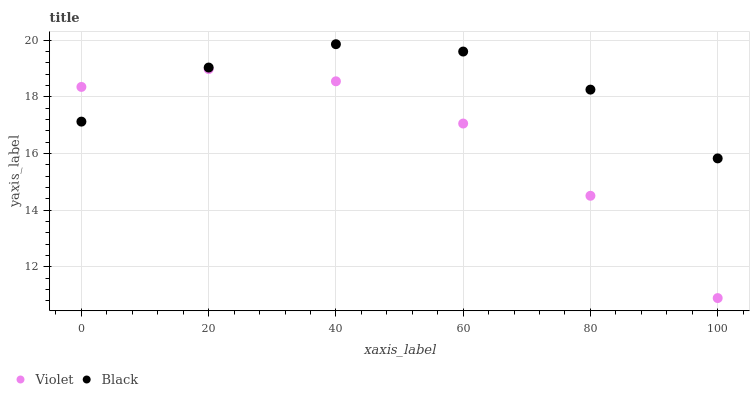Does Violet have the minimum area under the curve?
Answer yes or no. Yes. Does Black have the maximum area under the curve?
Answer yes or no. Yes. Does Violet have the maximum area under the curve?
Answer yes or no. No. Is Violet the smoothest?
Answer yes or no. Yes. Is Black the roughest?
Answer yes or no. Yes. Is Violet the roughest?
Answer yes or no. No. Does Violet have the lowest value?
Answer yes or no. Yes. Does Black have the highest value?
Answer yes or no. Yes. Does Violet have the highest value?
Answer yes or no. No. Does Black intersect Violet?
Answer yes or no. Yes. Is Black less than Violet?
Answer yes or no. No. Is Black greater than Violet?
Answer yes or no. No. 